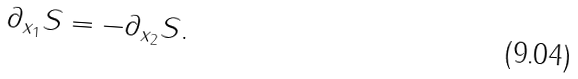<formula> <loc_0><loc_0><loc_500><loc_500>\partial _ { x _ { 1 } } S = - \partial _ { x _ { 2 } } S .</formula> 